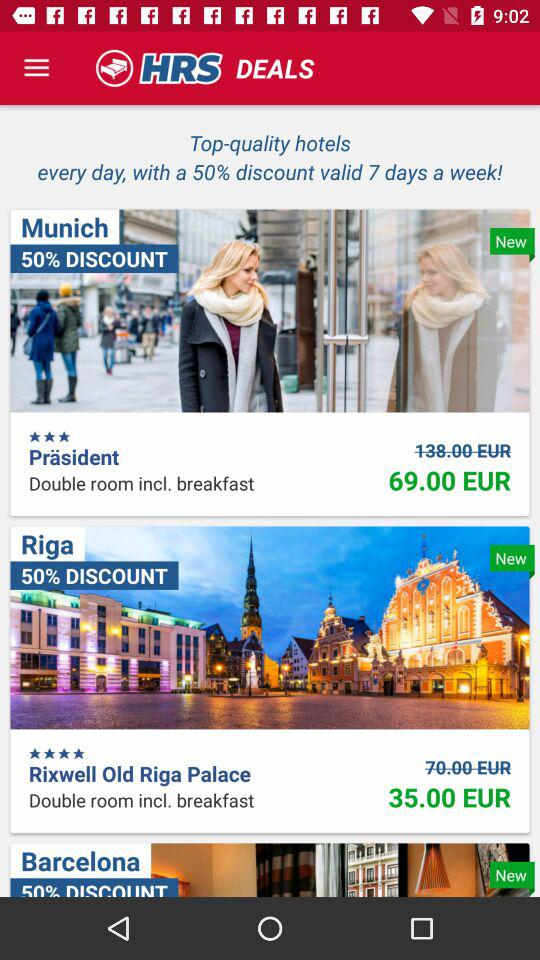What was the original rent for a double room in "Rixwell Old Riga Palace"? The original rent for a double room in "Rixwell Old Riga Palace" was 70 euros. 